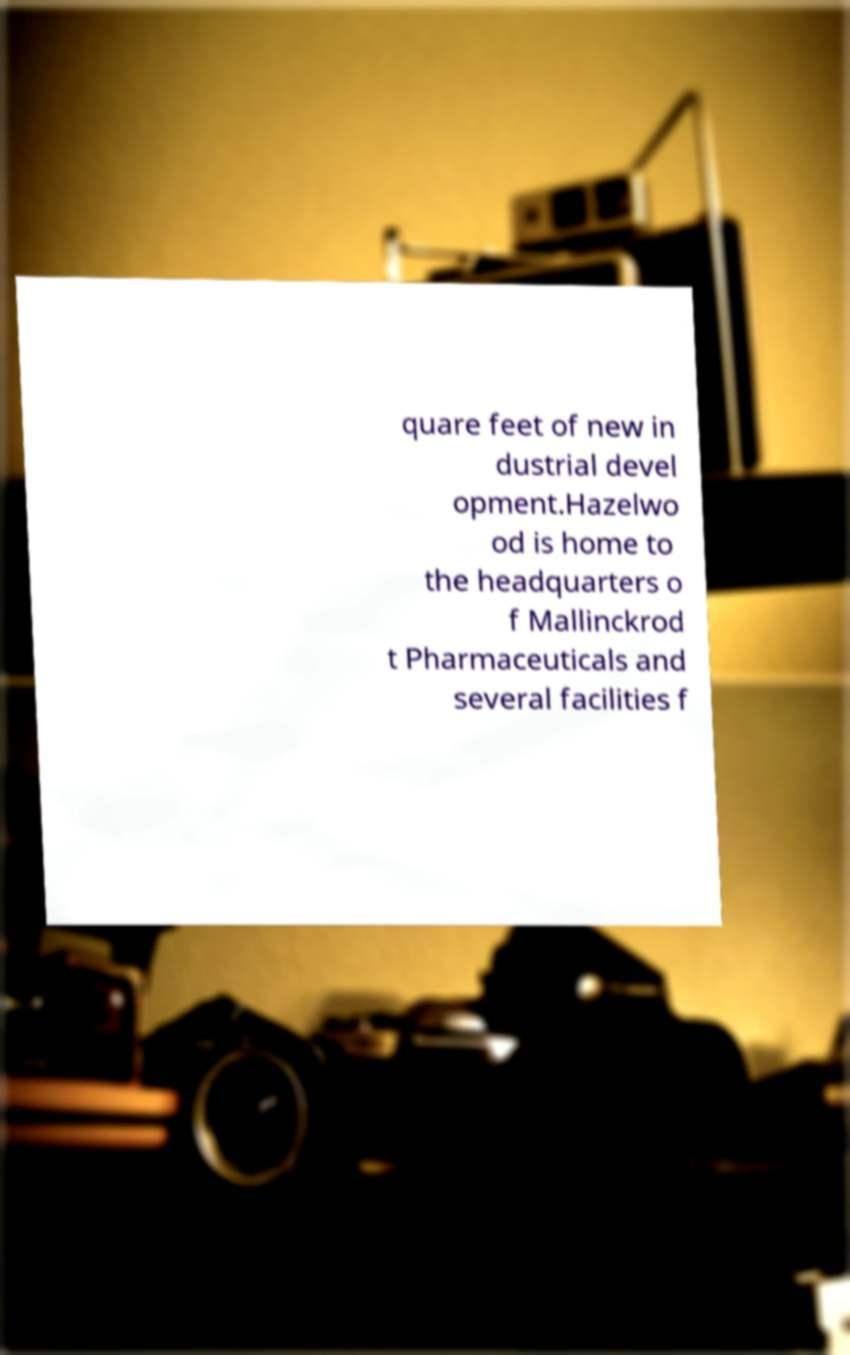Please identify and transcribe the text found in this image. quare feet of new in dustrial devel opment.Hazelwo od is home to the headquarters o f Mallinckrod t Pharmaceuticals and several facilities f 